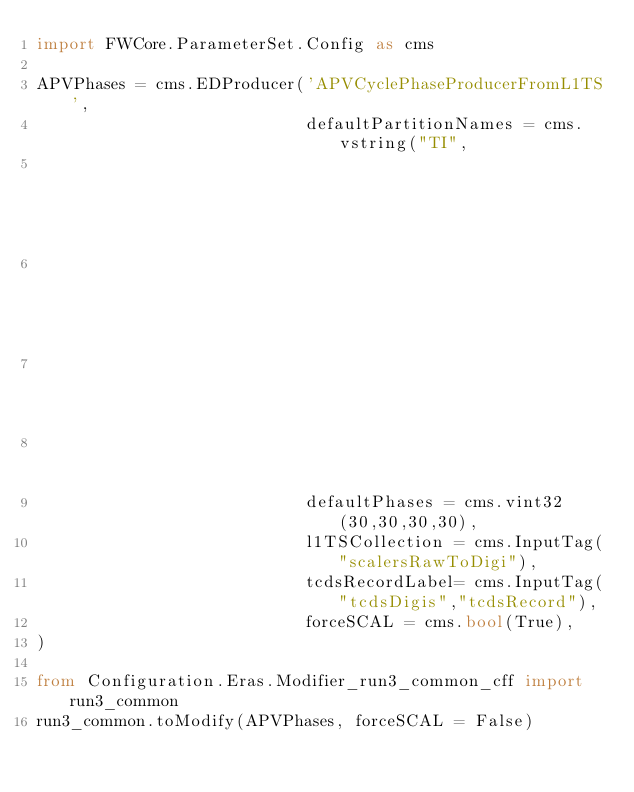<code> <loc_0><loc_0><loc_500><loc_500><_Python_>import FWCore.ParameterSet.Config as cms

APVPhases = cms.EDProducer('APVCyclePhaseProducerFromL1TS',
                           defaultPartitionNames = cms.vstring("TI",
                                                               "TO",
                                                               "TP",
                                                               "TM"
                                                               ),
                           defaultPhases = cms.vint32(30,30,30,30),
                           l1TSCollection = cms.InputTag("scalersRawToDigi"),
                           tcdsRecordLabel= cms.InputTag("tcdsDigis","tcdsRecord"),
                           forceSCAL = cms.bool(True),
)

from Configuration.Eras.Modifier_run3_common_cff import run3_common
run3_common.toModify(APVPhases, forceSCAL = False)
</code> 